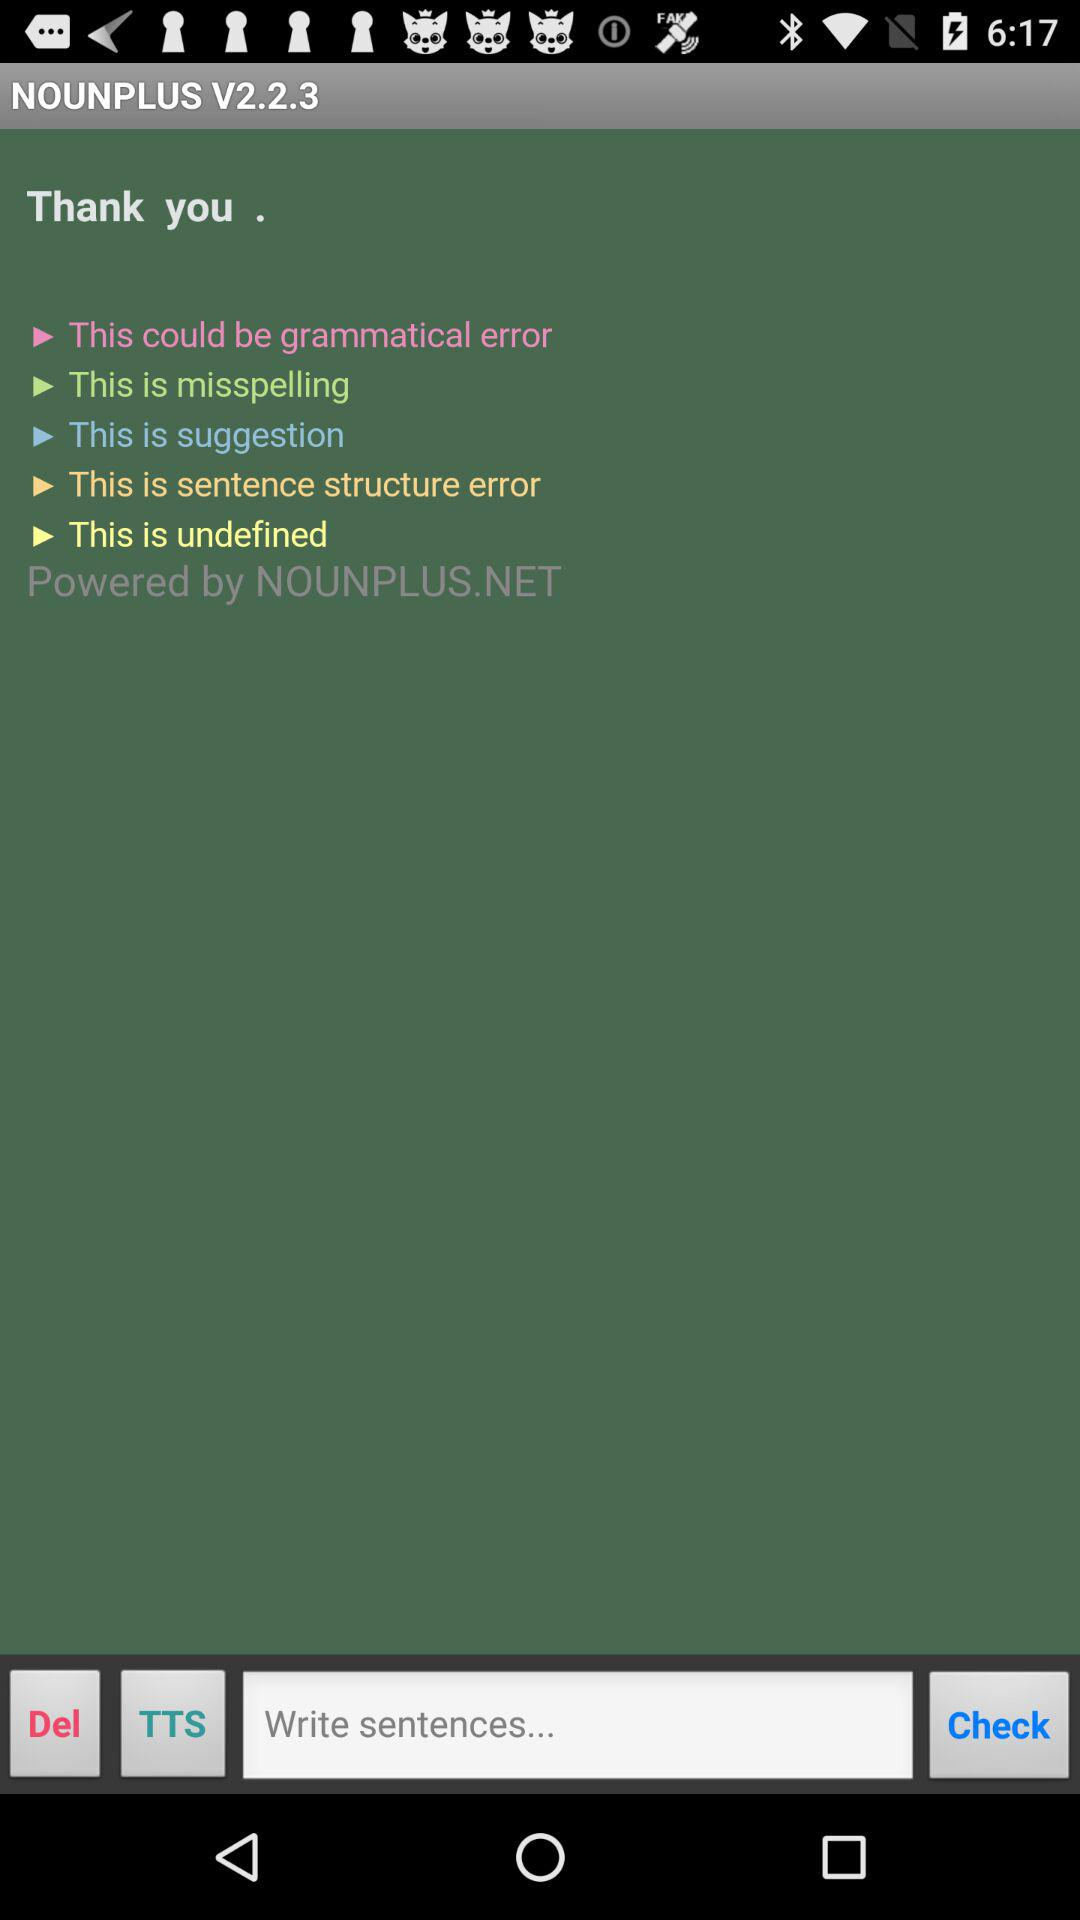By whom is the application powered? The application is powered by "NOUNPLUS.NET". 